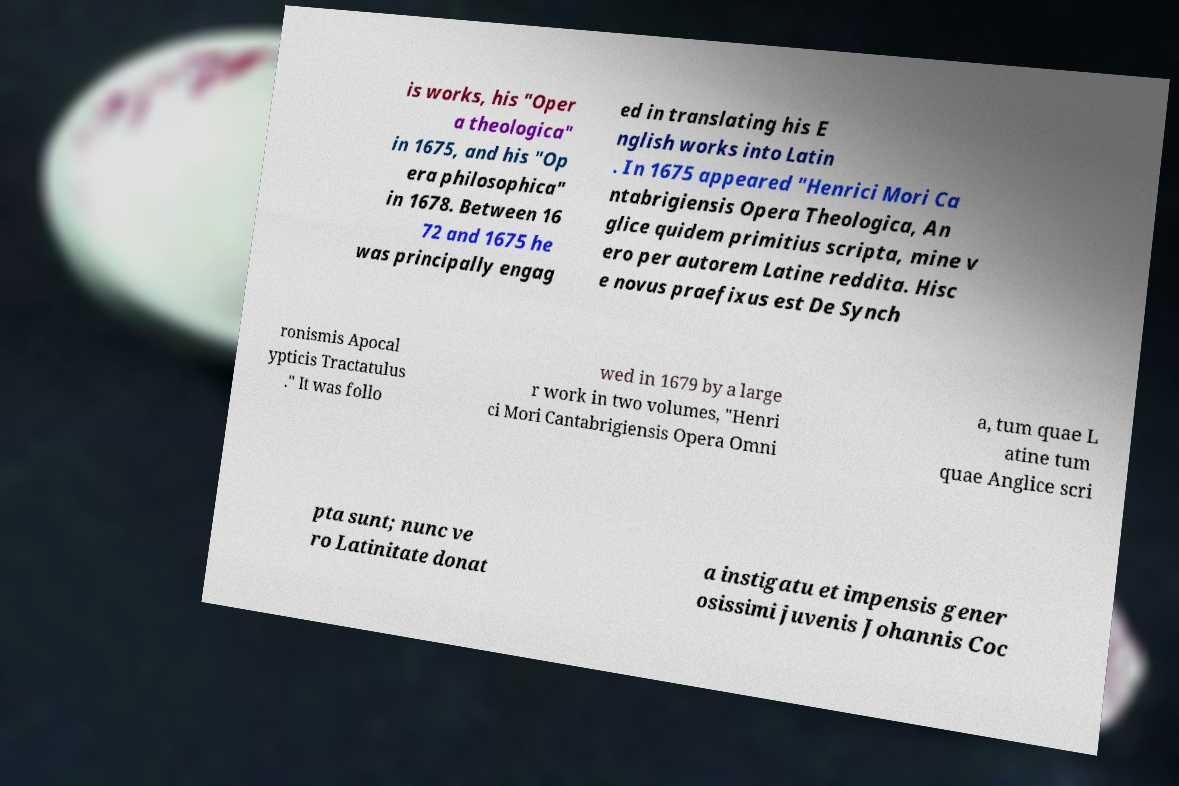Can you accurately transcribe the text from the provided image for me? is works, his "Oper a theologica" in 1675, and his "Op era philosophica" in 1678. Between 16 72 and 1675 he was principally engag ed in translating his E nglish works into Latin . In 1675 appeared "Henrici Mori Ca ntabrigiensis Opera Theologica, An glice quidem primitius scripta, mine v ero per autorem Latine reddita. Hisc e novus praefixus est De Synch ronismis Apocal ypticis Tractatulus ." It was follo wed in 1679 by a large r work in two volumes, "Henri ci Mori Cantabrigiensis Opera Omni a, tum quae L atine tum quae Anglice scri pta sunt; nunc ve ro Latinitate donat a instigatu et impensis gener osissimi juvenis Johannis Coc 